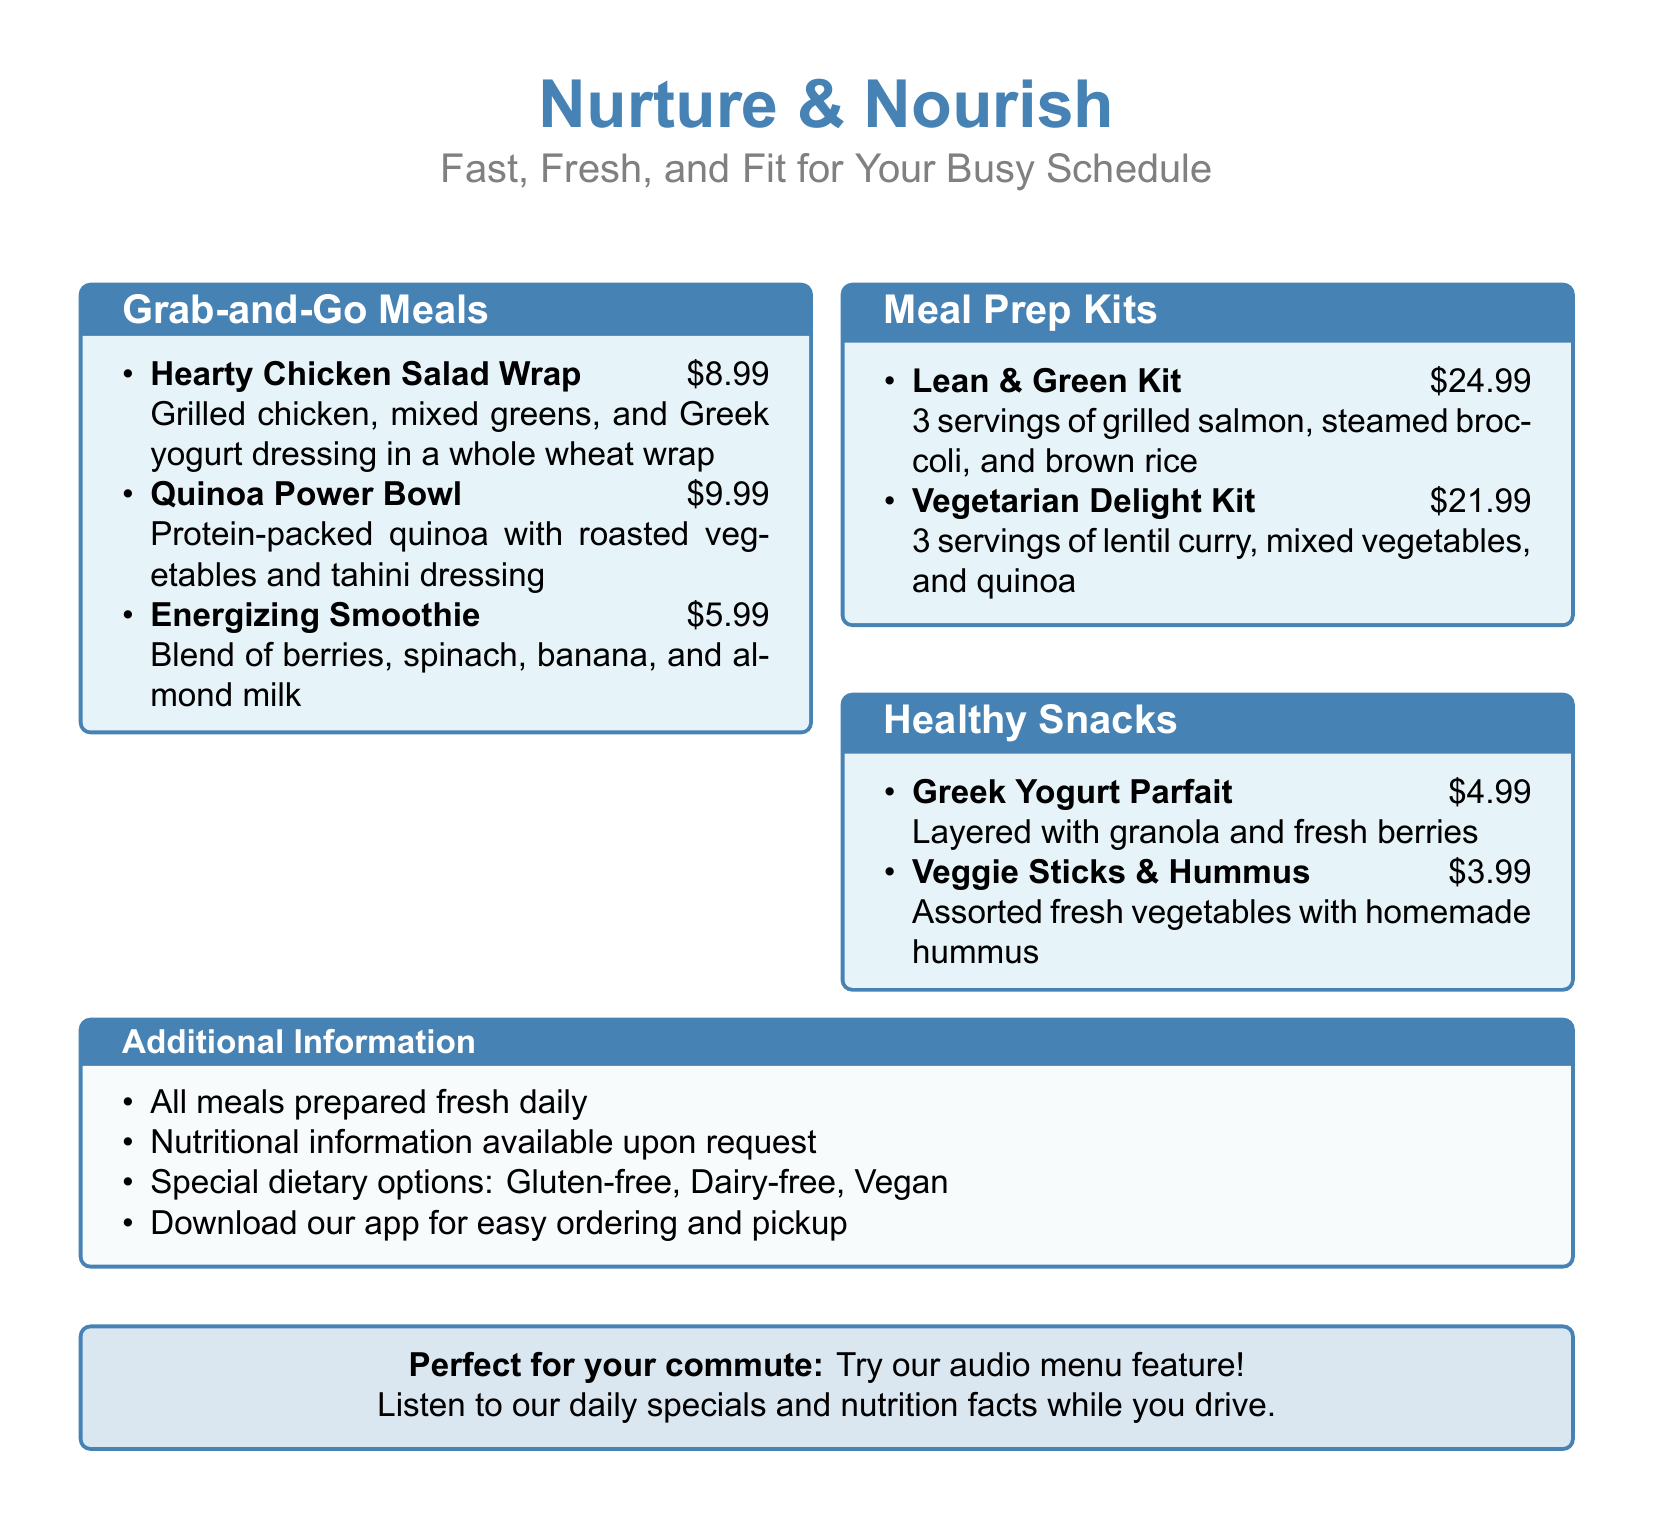What is the price of the Hearty Chicken Salad Wrap? The price of the Hearty Chicken Salad Wrap is listed in the Grab-and-Go Meals section of the menu.
Answer: $8.99 How many servings are included in the Lean & Green Kit? The Lean & Green Kit provides a specific number of servings, which is mentioned in the Meal Prep Kits section.
Answer: 3 servings What is the main ingredient in the Vegetarian Delight Kit? The main ingredient of the Vegetarian Delight Kit is mentioned in the description of the kit in the Meal Prep Kits section.
Answer: Lentil curry What type of dressing is used in the Quinoa Power Bowl? The type of dressing for the Quinoa Power Bowl is specified in the description in the Grab-and-Go Meals section.
Answer: Tahini dressing What healthy snack is mentioned with Greek yogurt? The healthy snack that includes Greek yogurt is noted in the Healthy Snacks section of the menu.
Answer: Greek Yogurt Parfait Which menu item costs less than $5? The menu lists items, and one of them is below the specified price in the Healthy Snacks section.
Answer: Veggie Sticks & Hummus What is the culinary style of the meals offered? The document presents a theme or description of the meal offerings that indicates their culinary style.
Answer: Fast, Fresh, and Fit Is there an app for ordering? The document mentions additional services related to ordering, indicating the availability of a mobile option.
Answer: Yes 